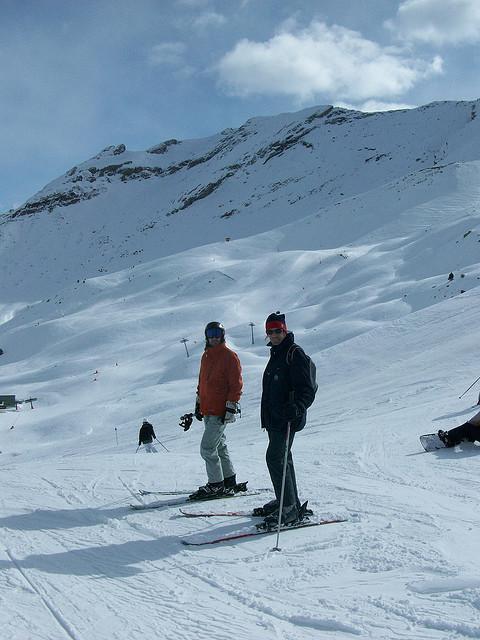How many people are skateboarding in this picture?
Give a very brief answer. 0. How many are wearing skis?
Give a very brief answer. 3. How many men are there present?
Give a very brief answer. 3. How many people can you see?
Give a very brief answer. 2. 